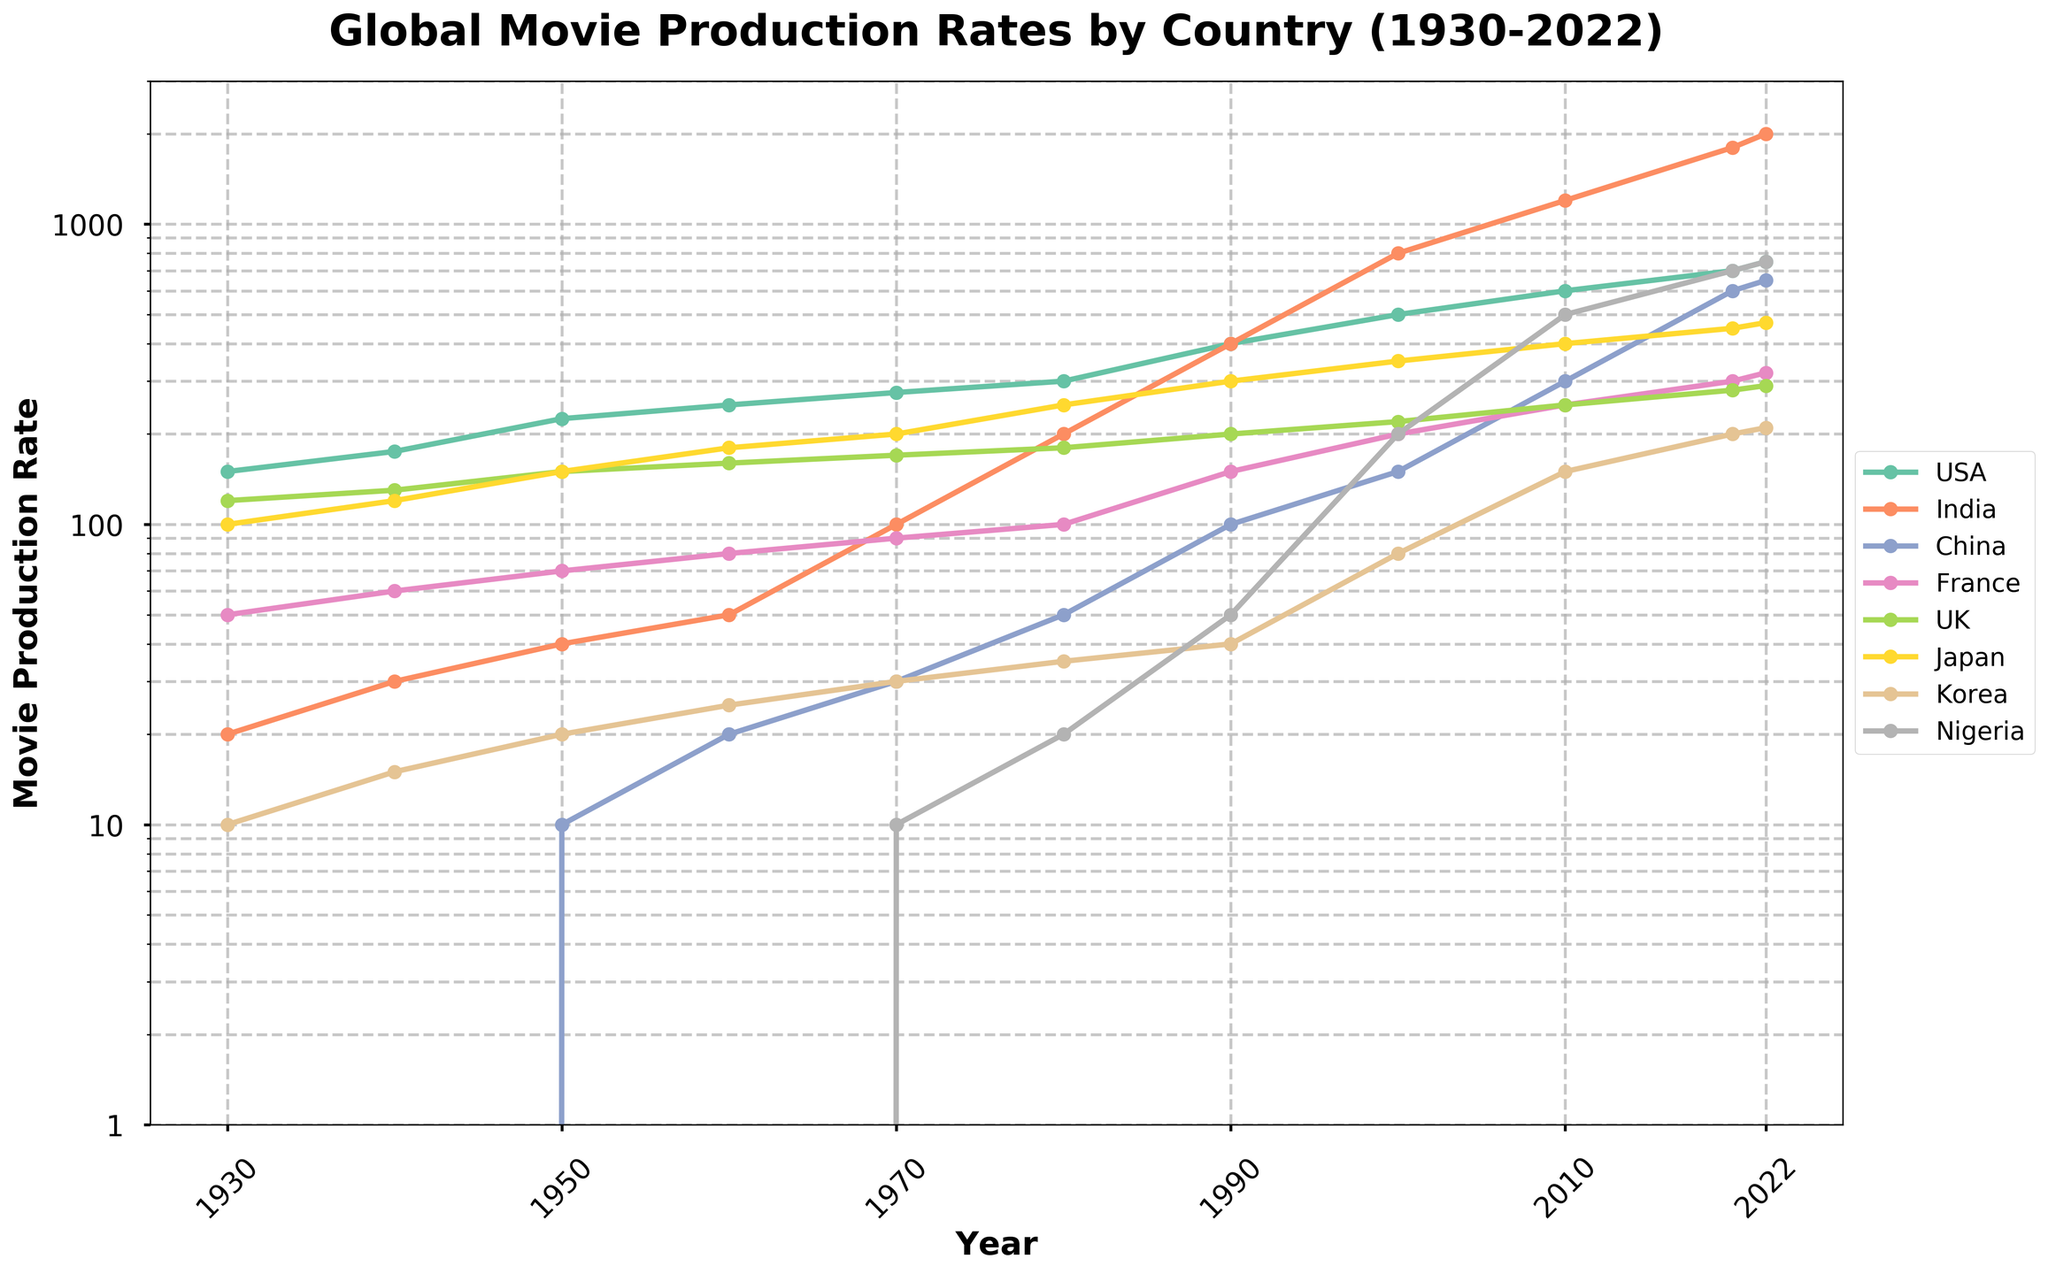What is the title of the figure? The title of the figure is located at the top and typically provides a summary of what the figure is about. In this case, it reads "Global Movie Production Rates by Country (1930-2022)."
Answer: Global Movie Production Rates by Country (1930-2022) Which country had the highest movie production rate in 2020? To find the highest movie production rate in 2020, look at the values corresponding to the year 2020 for each country line on the plot. The country with the highest rate in that year is India.
Answer: India How has the movie production rate for China changed from 1930 to 2022? Observe the line corresponding to China on the plot from 1930 to 2022. In 1930, the rate is at 0, and by 2022, it has increased to 650. This shows a significant upward trend over the years.
Answer: Increased from 0 to 650 In what year did India's movie production rate surpass 400? Follow the line for India and identify the year at which the production rate crosses the 400 mark. The year when this happens is 1990.
Answer: 1990 Which country shows the most consistent growth in movie production rates over the years? To determine the most consistent growth, observe the slope of the lines for each country. India's line shows a steady, strong rise without significant drops or plateaus, indicating consistent growth.
Answer: India By how much did Nigeria's movie production rate increase from 2010 to 2020? Look at the data points for Nigeria for the years 2010 and 2020. In 2010, the rate is 500, and in 2020, it's 700. The increase is calculated as 700 - 500 = 200.
Answer: 200 Compare the movie production rates of the USA and Japan in 1950. Which country had a higher rate and by how much? Find the data points for the USA and Japan in 1950. USA has 225 and Japan has 150. The difference is calculated as 225 - 150 = 75, with the USA having the higher rate.
Answer: USA by 75 How did France's movie production rate change from 1970 to the next decade, 1980? Check the values for France in 1970 and 1980. In 1970, the rate is 90, and in 1980, it's 100. The rate increased by 100 - 90 = 10 between these years.
Answer: Increased by 10 What is the movie production rate of the UK in the latest data year provided, 2022? Locate the UK line in the year 2022. The rate indicated for that year is 290.
Answer: 290 